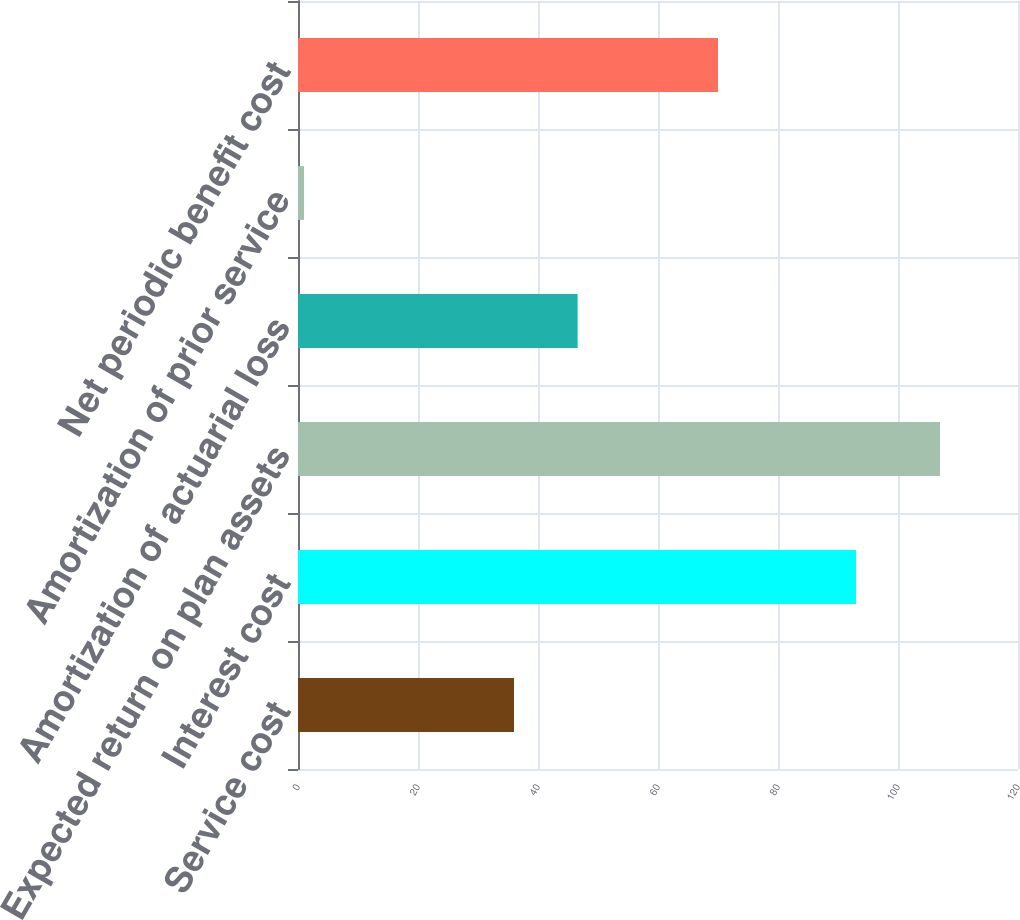Convert chart. <chart><loc_0><loc_0><loc_500><loc_500><bar_chart><fcel>Service cost<fcel>Interest cost<fcel>Expected return on plan assets<fcel>Amortization of actuarial loss<fcel>Amortization of prior service<fcel>Net periodic benefit cost<nl><fcel>36<fcel>93<fcel>107<fcel>46.6<fcel>1<fcel>70<nl></chart> 